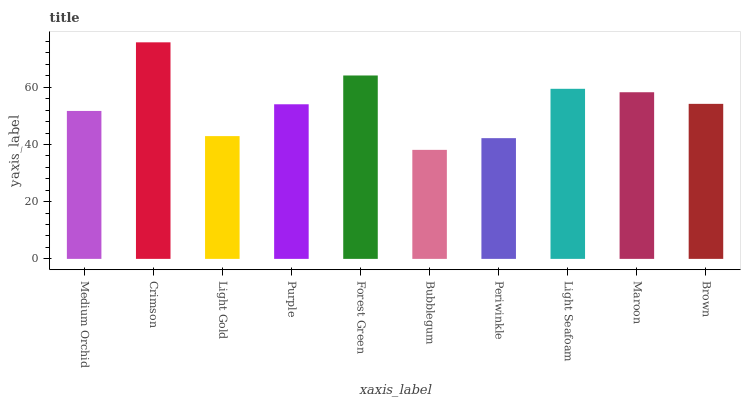Is Bubblegum the minimum?
Answer yes or no. Yes. Is Crimson the maximum?
Answer yes or no. Yes. Is Light Gold the minimum?
Answer yes or no. No. Is Light Gold the maximum?
Answer yes or no. No. Is Crimson greater than Light Gold?
Answer yes or no. Yes. Is Light Gold less than Crimson?
Answer yes or no. Yes. Is Light Gold greater than Crimson?
Answer yes or no. No. Is Crimson less than Light Gold?
Answer yes or no. No. Is Brown the high median?
Answer yes or no. Yes. Is Purple the low median?
Answer yes or no. Yes. Is Forest Green the high median?
Answer yes or no. No. Is Light Gold the low median?
Answer yes or no. No. 